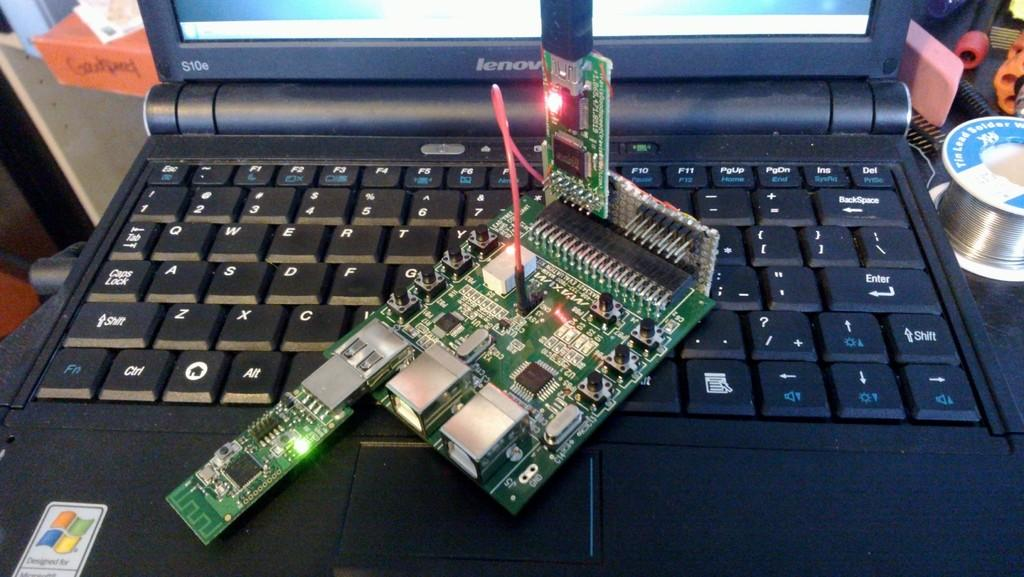<image>
Present a compact description of the photo's key features. The insides of a computer are resting on a Lenovo laptop keyboard. 